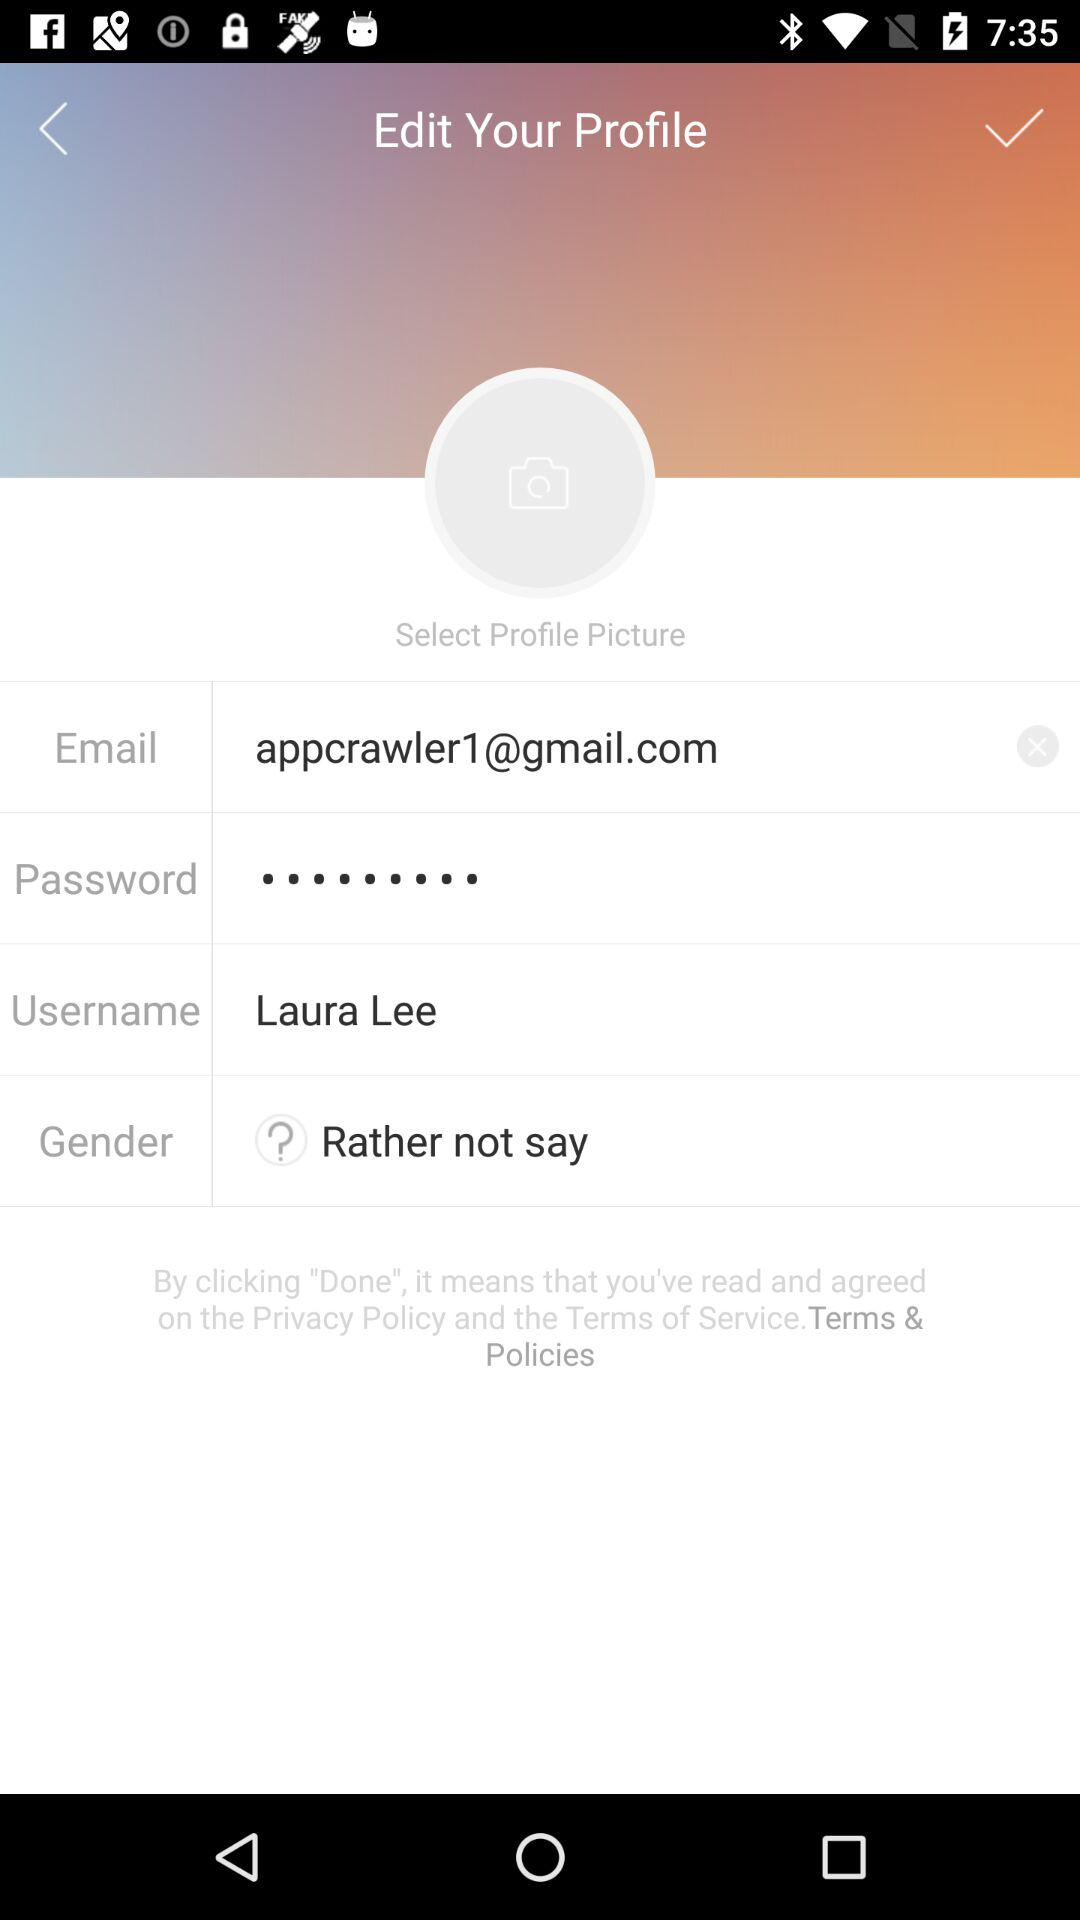How many inputs are required to change the profile?
Answer the question using a single word or phrase. 4 